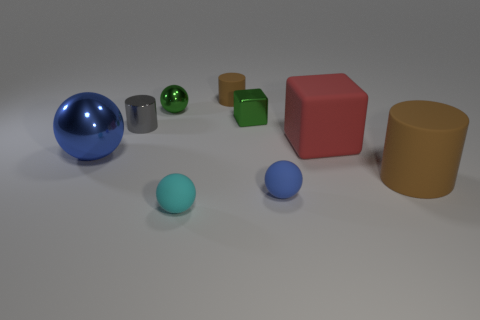Add 1 big cylinders. How many objects exist? 10 Subtract all cylinders. How many objects are left? 6 Subtract all brown objects. Subtract all cyan objects. How many objects are left? 6 Add 3 large blue balls. How many large blue balls are left? 4 Add 1 metal spheres. How many metal spheres exist? 3 Subtract 0 yellow cylinders. How many objects are left? 9 